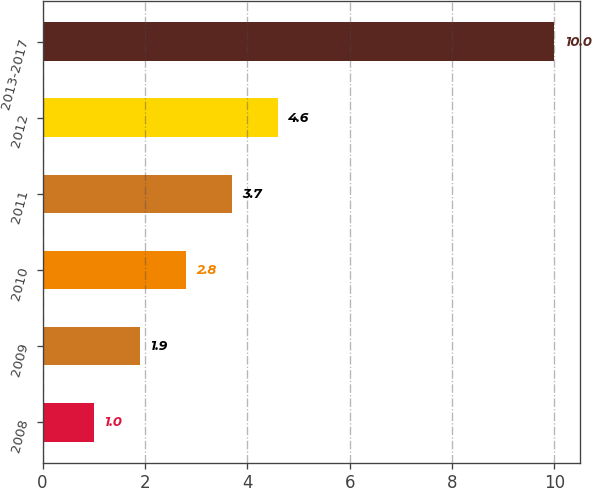Convert chart. <chart><loc_0><loc_0><loc_500><loc_500><bar_chart><fcel>2008<fcel>2009<fcel>2010<fcel>2011<fcel>2012<fcel>2013-2017<nl><fcel>1<fcel>1.9<fcel>2.8<fcel>3.7<fcel>4.6<fcel>10<nl></chart> 